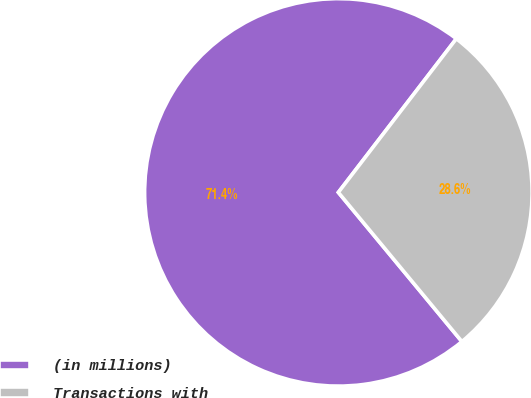Convert chart to OTSL. <chart><loc_0><loc_0><loc_500><loc_500><pie_chart><fcel>(in millions)<fcel>Transactions with<nl><fcel>71.43%<fcel>28.57%<nl></chart> 